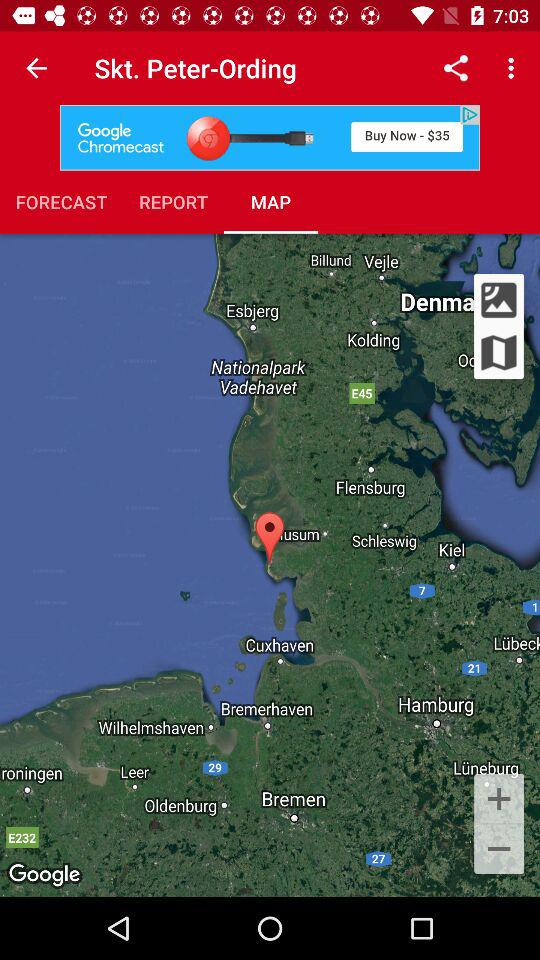What is the mentioned location? The mentioned location is Skt. Peter-Ording. 